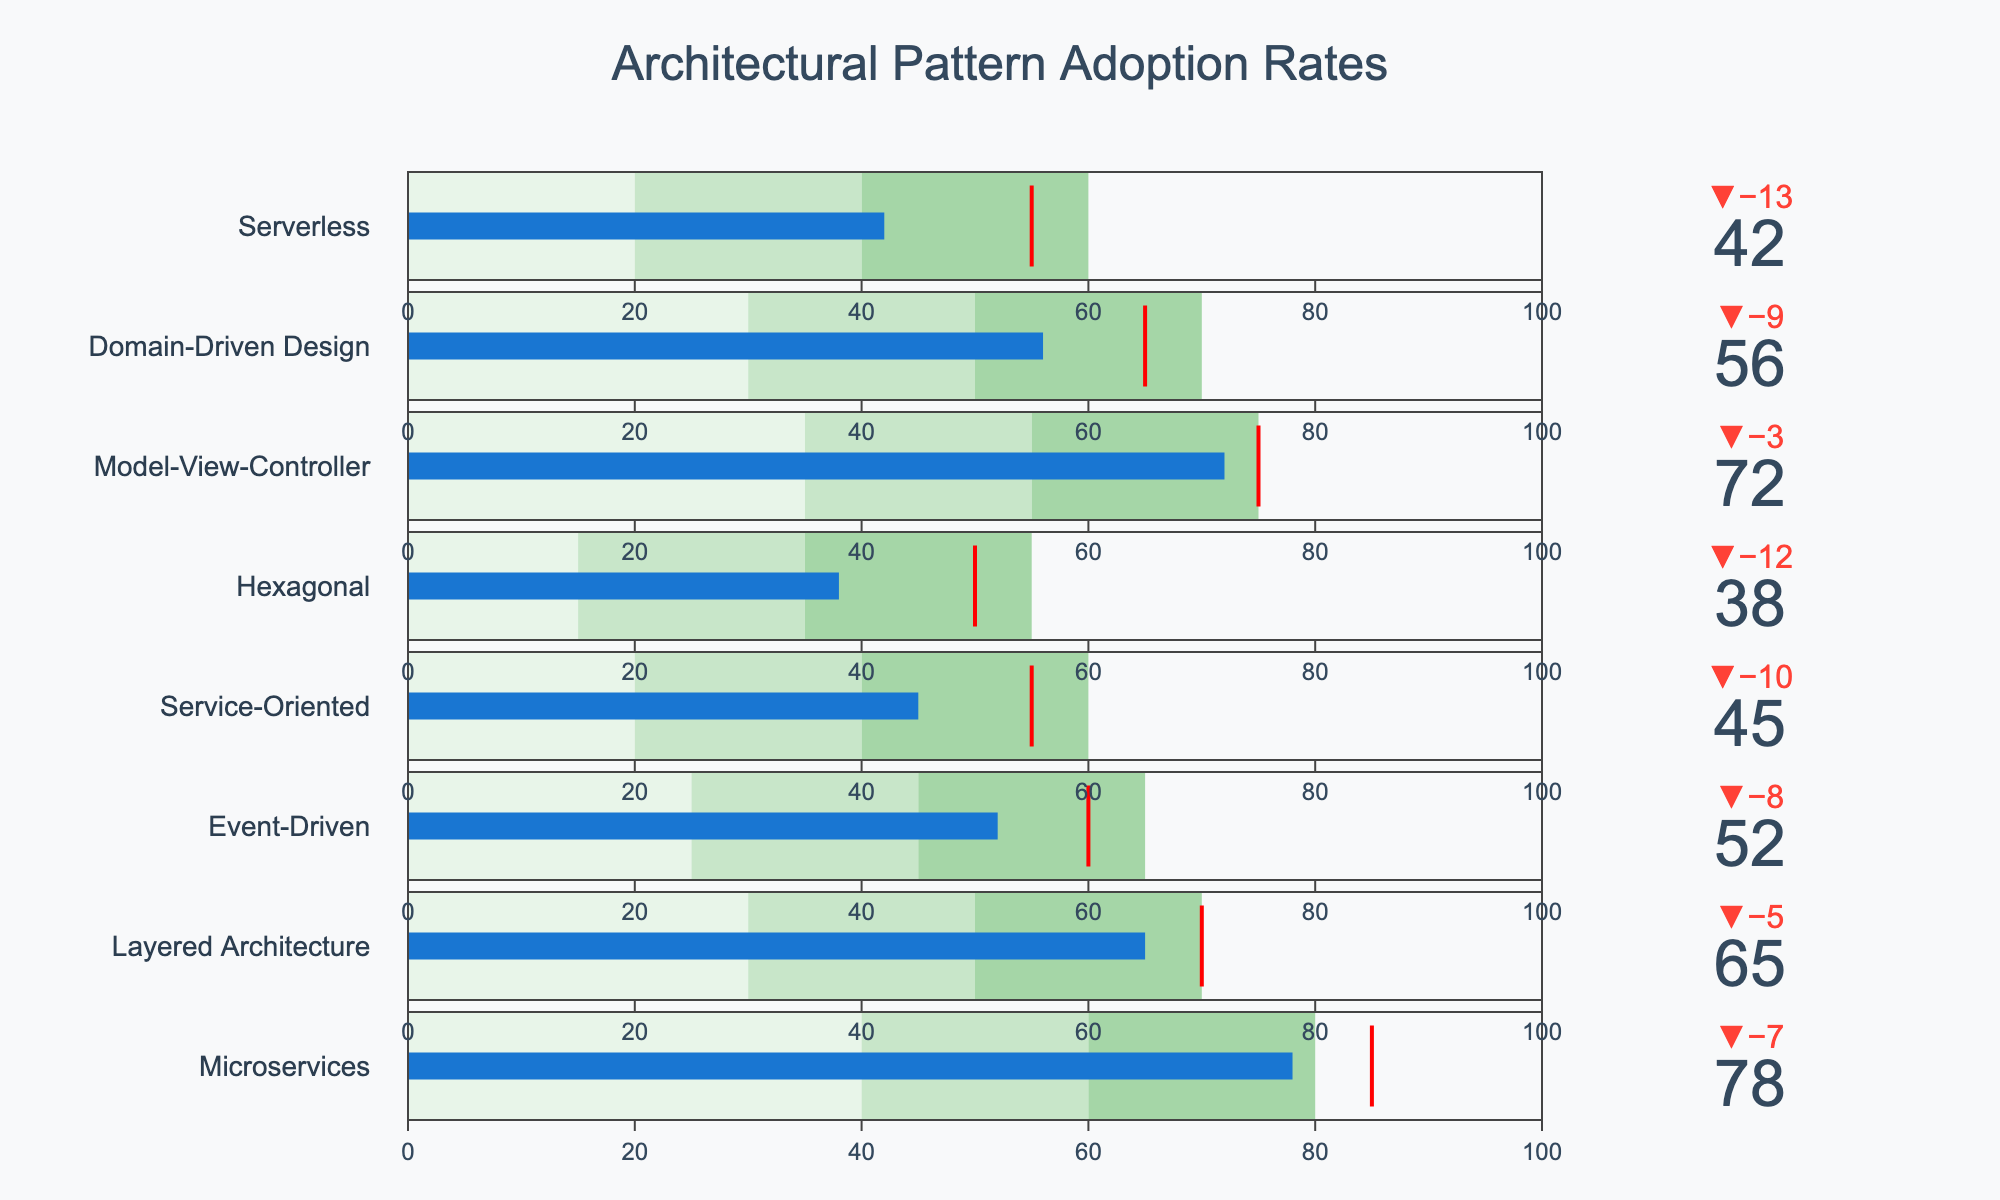What is the title of the chart? The title appears at the top of the chart and gives an overview of the chart's content. In this case, the title reads "Architectural Pattern Adoption Rates".
Answer: Architectural Pattern Adoption Rates Which architectural pattern has the highest actual adoption rate? By examining the "Actual" value for each pattern, we see that "Microservices" has the highest actual adoption rate listed as 78.
Answer: Microservices How many architectural patterns have actual adoption rates higher than their target? Comparing the "Actual" rates to the "Target" rates for each pattern, we find that "Microservices", "Model-View-Controller", and "Layered Architecture" exceed their targets.
Answer: Three Which architectural pattern has the biggest difference between its actual and target adoption rates? Calculating the difference for each pattern, "Domain-Driven Design" has the largest difference where the actual rate (56) is significantly less than the target rate (65), resulting in a difference of -9.
Answer: Domain-Driven Design What is the target adoption rate for the Event-Driven architecture? The target for each pattern is marked by a threshold line in red. The Event-Driven architecture's target rate is specified as 60.
Answer: 60 What is the approximate range covered in green for the Hexagonal architecture? The chart uses different colors to represent ranges. Green for the Hexagonal architecture spans from 35 to 55.
Answer: 35 to 55 Between Service-Oriented and Serverless architectures, which one has a closer actual adoption rate to its target? Comparing their actual to target differences: Service-Oriented (45 actual, 55 target) is 10 units away; Serverless (42 actual, 55 target) is 13 units away. Service-Oriented is closer.
Answer: Service-Oriented What colors represent the different ranges in this bullet chart? From lightest to darkest, the colors used for ranges are light green, medium green, and dark green.
Answer: Light green, medium green, dark green Which architectural pattern has an actual adoption rate closer to its range 2 upper limit, Microservices or Model-View-Controller? For Microservices, range 2 upper limit is 60 (actual is 78). For Model-View-Controller, range 2 upper limit is 55 (actual is 72). Both exceed their range 2, but Microservices exceeds it by a larger margin.
Answer: Model-View-Controller What does the red line represent in this figure? The red line in each bullet chart represents the target adoption rate for that architectural pattern.
Answer: Target adoption rate 